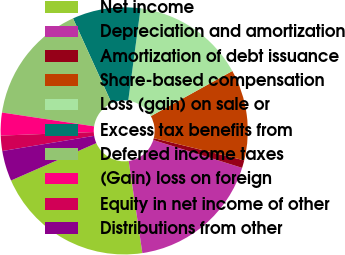<chart> <loc_0><loc_0><loc_500><loc_500><pie_chart><fcel>Net income<fcel>Depreciation and amortization<fcel>Amortization of debt issuance<fcel>Share-based compensation<fcel>Loss (gain) on sale or<fcel>Excess tax benefits from<fcel>Deferred income taxes<fcel>(Gain) loss on foreign<fcel>Equity in net income of other<fcel>Distributions from other<nl><fcel>20.77%<fcel>17.81%<fcel>1.01%<fcel>11.88%<fcel>14.84%<fcel>8.91%<fcel>15.83%<fcel>2.98%<fcel>2.0%<fcel>3.97%<nl></chart> 